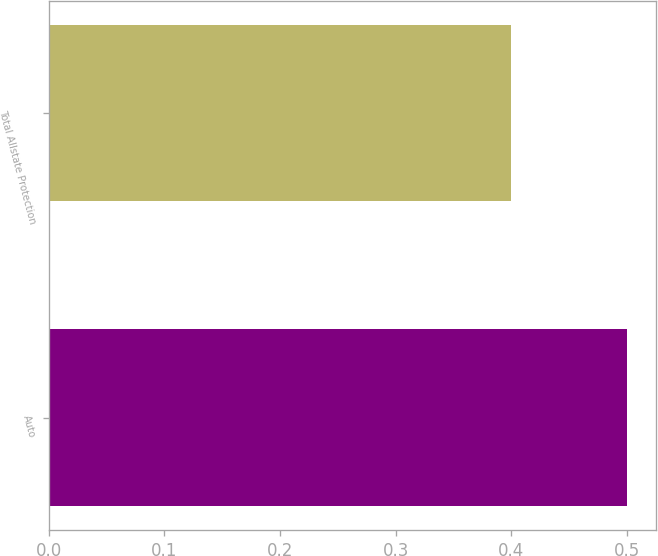Convert chart to OTSL. <chart><loc_0><loc_0><loc_500><loc_500><bar_chart><fcel>Auto<fcel>Total Allstate Protection<nl><fcel>0.5<fcel>0.4<nl></chart> 